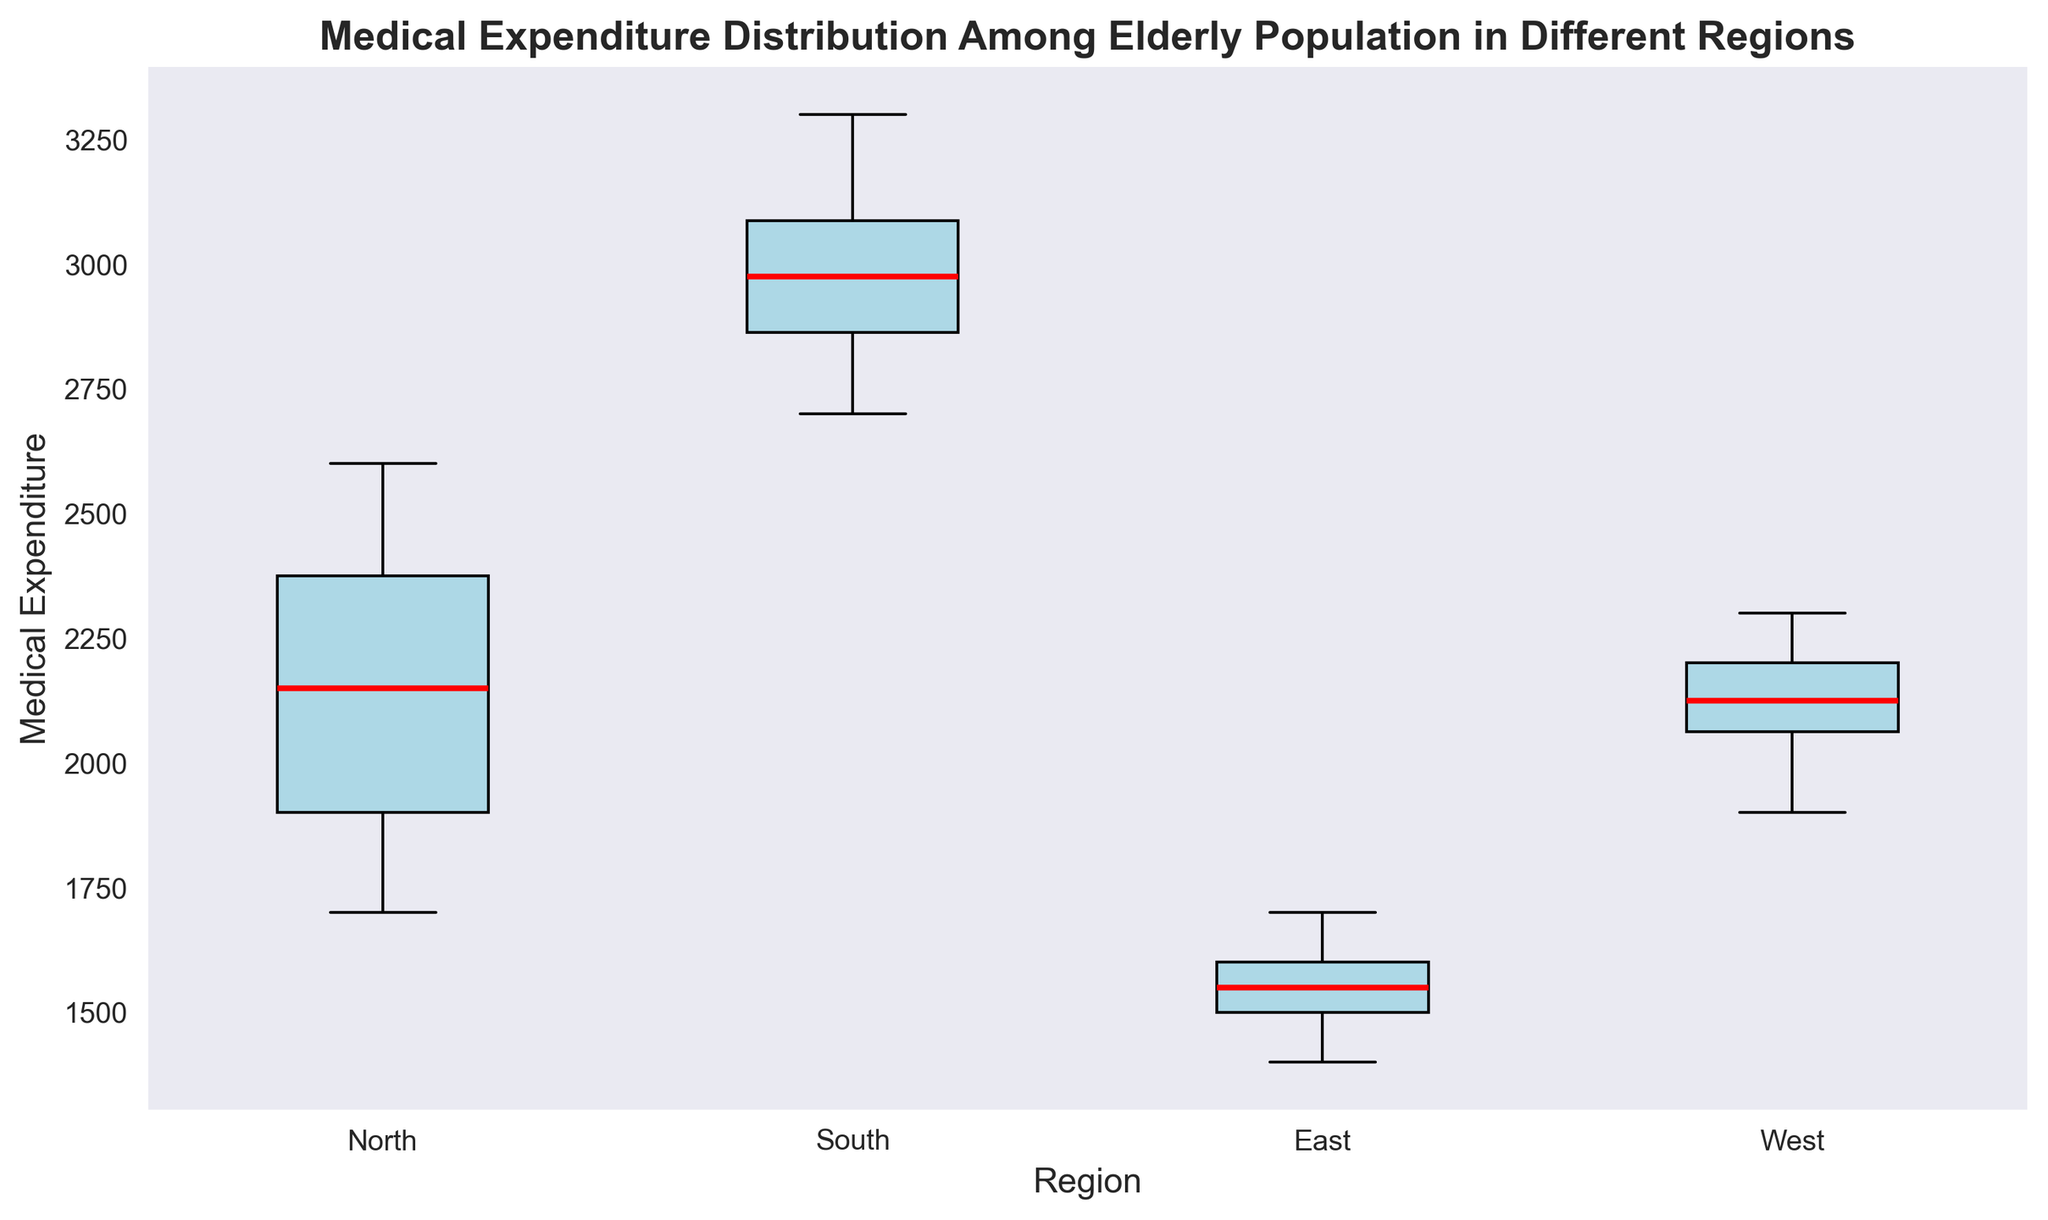What is the region with the highest median medical expenditure? First, find the median line within each box. The region with the highest median line is the region with the highest median medical expenditure.
Answer: South What is the difference between the median medical expenditure of the South and East regions? Identify the median line within each box for the South and East regions. The median for the South is 3000, and for the East is 1550. Calculate the difference (3000 - 1550).
Answer: 1450 Which region has the smallest interquartile range (IQR) for medical expenditure? The IQR is the range between the lower quartile (bottom of the box) and the upper quartile (top of the box). Visually inspect each region's IQR by the height of the box and select the smallest.
Answer: East How does the variability of medical expenditure in the West compare to the North? Compare the heights of the boxes and the lengths of the whiskers for both regions. The West has a smaller variability indicated by a shorter box and whiskers compared to the North.
Answer: The West has lower variability Which region has the least number of data points represented as outliers? Outliers are represented as individual points outside the whiskers. Count the outliers for each region. The East has no outliers.
Answer: East What is the range of medical expenditure in the North region? Identify the smallest and largest points in the North region from the whiskers. Subtract the smallest value from the largest (2600 - 1700).
Answer: 900 Does any region have overlapping ranges of medical expenditure? If yes, which ones? Compare the ranges (minimum to maximum whiskers) across regions for overlaps. The North and West ranges overlap between 1900 and 2600.
Answer: North and West What is the highest medical expenditure recorded, and in which region? Look for the highest point among all whiskers or outliers. The highest point is 3300 in the South region.
Answer: 3300, South Which region has the most skewed distribution of medical expenditure? Look for asymmetry in the box and whiskers. The South might be slightly right-skewed, but none appear very skewed.
Answer: South (slightly) Compare the median medical expenditures of all regions. Rank them from highest to lowest. Identify the median lines within each box for all regions and rank them by their height.
Answer: South > North > West > East 